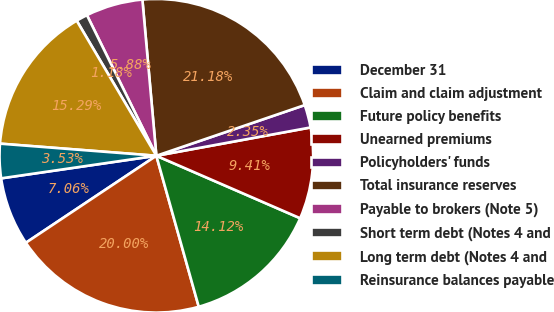<chart> <loc_0><loc_0><loc_500><loc_500><pie_chart><fcel>December 31<fcel>Claim and claim adjustment<fcel>Future policy benefits<fcel>Unearned premiums<fcel>Policyholders' funds<fcel>Total insurance reserves<fcel>Payable to brokers (Note 5)<fcel>Short term debt (Notes 4 and<fcel>Long term debt (Notes 4 and<fcel>Reinsurance balances payable<nl><fcel>7.06%<fcel>20.0%<fcel>14.12%<fcel>9.41%<fcel>2.35%<fcel>21.18%<fcel>5.88%<fcel>1.18%<fcel>15.29%<fcel>3.53%<nl></chart> 